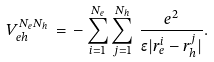Convert formula to latex. <formula><loc_0><loc_0><loc_500><loc_500>V _ { e h } ^ { N _ { e } N _ { h } } \, = \, - \sum _ { i = 1 } ^ { N _ { e } } \sum _ { j = 1 } ^ { N _ { h } } \, \frac { e ^ { 2 } } { \epsilon | r _ { e } ^ { i } - r _ { h } ^ { j } | } .</formula> 